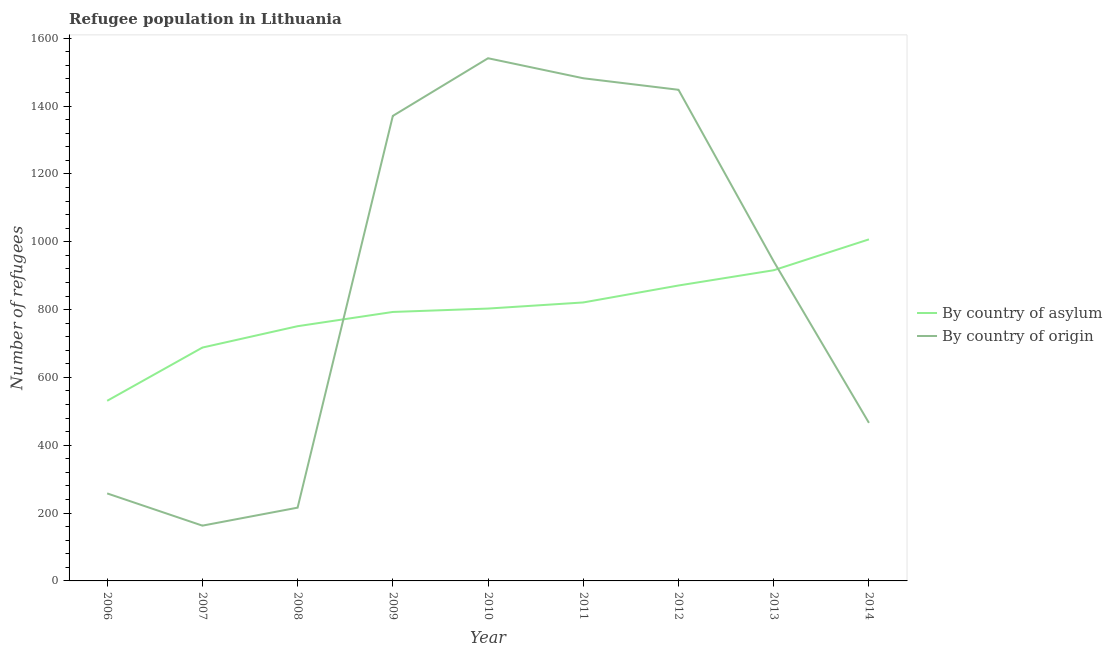How many different coloured lines are there?
Your answer should be very brief. 2. Does the line corresponding to number of refugees by country of asylum intersect with the line corresponding to number of refugees by country of origin?
Give a very brief answer. Yes. What is the number of refugees by country of asylum in 2012?
Provide a short and direct response. 871. Across all years, what is the maximum number of refugees by country of asylum?
Ensure brevity in your answer.  1007. Across all years, what is the minimum number of refugees by country of origin?
Make the answer very short. 163. In which year was the number of refugees by country of asylum minimum?
Keep it short and to the point. 2006. What is the total number of refugees by country of asylum in the graph?
Your answer should be very brief. 7181. What is the difference between the number of refugees by country of asylum in 2008 and that in 2013?
Your response must be concise. -165. What is the difference between the number of refugees by country of origin in 2008 and the number of refugees by country of asylum in 2007?
Your answer should be very brief. -472. What is the average number of refugees by country of origin per year?
Offer a terse response. 876.33. In the year 2011, what is the difference between the number of refugees by country of asylum and number of refugees by country of origin?
Ensure brevity in your answer.  -661. What is the ratio of the number of refugees by country of origin in 2011 to that in 2014?
Your answer should be very brief. 3.18. What is the difference between the highest and the second highest number of refugees by country of asylum?
Ensure brevity in your answer.  91. What is the difference between the highest and the lowest number of refugees by country of origin?
Offer a terse response. 1378. In how many years, is the number of refugees by country of origin greater than the average number of refugees by country of origin taken over all years?
Your answer should be very brief. 5. Is the sum of the number of refugees by country of origin in 2011 and 2012 greater than the maximum number of refugees by country of asylum across all years?
Your answer should be very brief. Yes. Is the number of refugees by country of asylum strictly greater than the number of refugees by country of origin over the years?
Give a very brief answer. No. Is the number of refugees by country of origin strictly less than the number of refugees by country of asylum over the years?
Ensure brevity in your answer.  No. How many lines are there?
Your response must be concise. 2. Does the graph contain any zero values?
Make the answer very short. No. Where does the legend appear in the graph?
Ensure brevity in your answer.  Center right. How are the legend labels stacked?
Keep it short and to the point. Vertical. What is the title of the graph?
Your answer should be compact. Refugee population in Lithuania. What is the label or title of the X-axis?
Your answer should be very brief. Year. What is the label or title of the Y-axis?
Give a very brief answer. Number of refugees. What is the Number of refugees of By country of asylum in 2006?
Keep it short and to the point. 531. What is the Number of refugees in By country of origin in 2006?
Provide a succinct answer. 258. What is the Number of refugees of By country of asylum in 2007?
Your answer should be very brief. 688. What is the Number of refugees of By country of origin in 2007?
Your answer should be compact. 163. What is the Number of refugees of By country of asylum in 2008?
Ensure brevity in your answer.  751. What is the Number of refugees in By country of origin in 2008?
Keep it short and to the point. 216. What is the Number of refugees in By country of asylum in 2009?
Your answer should be compact. 793. What is the Number of refugees of By country of origin in 2009?
Offer a terse response. 1371. What is the Number of refugees of By country of asylum in 2010?
Ensure brevity in your answer.  803. What is the Number of refugees of By country of origin in 2010?
Offer a terse response. 1541. What is the Number of refugees in By country of asylum in 2011?
Give a very brief answer. 821. What is the Number of refugees in By country of origin in 2011?
Offer a terse response. 1482. What is the Number of refugees of By country of asylum in 2012?
Your response must be concise. 871. What is the Number of refugees in By country of origin in 2012?
Provide a short and direct response. 1448. What is the Number of refugees of By country of asylum in 2013?
Keep it short and to the point. 916. What is the Number of refugees in By country of origin in 2013?
Provide a short and direct response. 942. What is the Number of refugees of By country of asylum in 2014?
Your answer should be compact. 1007. What is the Number of refugees of By country of origin in 2014?
Ensure brevity in your answer.  466. Across all years, what is the maximum Number of refugees of By country of asylum?
Ensure brevity in your answer.  1007. Across all years, what is the maximum Number of refugees of By country of origin?
Your response must be concise. 1541. Across all years, what is the minimum Number of refugees in By country of asylum?
Offer a terse response. 531. Across all years, what is the minimum Number of refugees of By country of origin?
Ensure brevity in your answer.  163. What is the total Number of refugees in By country of asylum in the graph?
Your response must be concise. 7181. What is the total Number of refugees of By country of origin in the graph?
Offer a terse response. 7887. What is the difference between the Number of refugees of By country of asylum in 2006 and that in 2007?
Provide a succinct answer. -157. What is the difference between the Number of refugees of By country of origin in 2006 and that in 2007?
Offer a very short reply. 95. What is the difference between the Number of refugees in By country of asylum in 2006 and that in 2008?
Ensure brevity in your answer.  -220. What is the difference between the Number of refugees in By country of origin in 2006 and that in 2008?
Your answer should be compact. 42. What is the difference between the Number of refugees of By country of asylum in 2006 and that in 2009?
Keep it short and to the point. -262. What is the difference between the Number of refugees of By country of origin in 2006 and that in 2009?
Offer a very short reply. -1113. What is the difference between the Number of refugees in By country of asylum in 2006 and that in 2010?
Keep it short and to the point. -272. What is the difference between the Number of refugees in By country of origin in 2006 and that in 2010?
Give a very brief answer. -1283. What is the difference between the Number of refugees of By country of asylum in 2006 and that in 2011?
Give a very brief answer. -290. What is the difference between the Number of refugees in By country of origin in 2006 and that in 2011?
Your response must be concise. -1224. What is the difference between the Number of refugees of By country of asylum in 2006 and that in 2012?
Keep it short and to the point. -340. What is the difference between the Number of refugees of By country of origin in 2006 and that in 2012?
Give a very brief answer. -1190. What is the difference between the Number of refugees in By country of asylum in 2006 and that in 2013?
Make the answer very short. -385. What is the difference between the Number of refugees of By country of origin in 2006 and that in 2013?
Provide a succinct answer. -684. What is the difference between the Number of refugees of By country of asylum in 2006 and that in 2014?
Your response must be concise. -476. What is the difference between the Number of refugees in By country of origin in 2006 and that in 2014?
Offer a very short reply. -208. What is the difference between the Number of refugees of By country of asylum in 2007 and that in 2008?
Offer a very short reply. -63. What is the difference between the Number of refugees of By country of origin in 2007 and that in 2008?
Your answer should be very brief. -53. What is the difference between the Number of refugees of By country of asylum in 2007 and that in 2009?
Give a very brief answer. -105. What is the difference between the Number of refugees in By country of origin in 2007 and that in 2009?
Make the answer very short. -1208. What is the difference between the Number of refugees in By country of asylum in 2007 and that in 2010?
Provide a succinct answer. -115. What is the difference between the Number of refugees in By country of origin in 2007 and that in 2010?
Provide a succinct answer. -1378. What is the difference between the Number of refugees in By country of asylum in 2007 and that in 2011?
Your answer should be very brief. -133. What is the difference between the Number of refugees of By country of origin in 2007 and that in 2011?
Your answer should be compact. -1319. What is the difference between the Number of refugees in By country of asylum in 2007 and that in 2012?
Keep it short and to the point. -183. What is the difference between the Number of refugees in By country of origin in 2007 and that in 2012?
Your response must be concise. -1285. What is the difference between the Number of refugees of By country of asylum in 2007 and that in 2013?
Ensure brevity in your answer.  -228. What is the difference between the Number of refugees in By country of origin in 2007 and that in 2013?
Give a very brief answer. -779. What is the difference between the Number of refugees of By country of asylum in 2007 and that in 2014?
Provide a short and direct response. -319. What is the difference between the Number of refugees of By country of origin in 2007 and that in 2014?
Offer a terse response. -303. What is the difference between the Number of refugees of By country of asylum in 2008 and that in 2009?
Ensure brevity in your answer.  -42. What is the difference between the Number of refugees in By country of origin in 2008 and that in 2009?
Ensure brevity in your answer.  -1155. What is the difference between the Number of refugees in By country of asylum in 2008 and that in 2010?
Provide a succinct answer. -52. What is the difference between the Number of refugees in By country of origin in 2008 and that in 2010?
Your answer should be compact. -1325. What is the difference between the Number of refugees of By country of asylum in 2008 and that in 2011?
Offer a very short reply. -70. What is the difference between the Number of refugees in By country of origin in 2008 and that in 2011?
Offer a terse response. -1266. What is the difference between the Number of refugees of By country of asylum in 2008 and that in 2012?
Ensure brevity in your answer.  -120. What is the difference between the Number of refugees of By country of origin in 2008 and that in 2012?
Give a very brief answer. -1232. What is the difference between the Number of refugees of By country of asylum in 2008 and that in 2013?
Make the answer very short. -165. What is the difference between the Number of refugees of By country of origin in 2008 and that in 2013?
Provide a short and direct response. -726. What is the difference between the Number of refugees of By country of asylum in 2008 and that in 2014?
Provide a succinct answer. -256. What is the difference between the Number of refugees in By country of origin in 2008 and that in 2014?
Offer a terse response. -250. What is the difference between the Number of refugees in By country of origin in 2009 and that in 2010?
Keep it short and to the point. -170. What is the difference between the Number of refugees of By country of asylum in 2009 and that in 2011?
Make the answer very short. -28. What is the difference between the Number of refugees in By country of origin in 2009 and that in 2011?
Give a very brief answer. -111. What is the difference between the Number of refugees of By country of asylum in 2009 and that in 2012?
Your response must be concise. -78. What is the difference between the Number of refugees of By country of origin in 2009 and that in 2012?
Your answer should be compact. -77. What is the difference between the Number of refugees in By country of asylum in 2009 and that in 2013?
Offer a very short reply. -123. What is the difference between the Number of refugees of By country of origin in 2009 and that in 2013?
Keep it short and to the point. 429. What is the difference between the Number of refugees in By country of asylum in 2009 and that in 2014?
Your answer should be very brief. -214. What is the difference between the Number of refugees in By country of origin in 2009 and that in 2014?
Make the answer very short. 905. What is the difference between the Number of refugees in By country of asylum in 2010 and that in 2011?
Ensure brevity in your answer.  -18. What is the difference between the Number of refugees in By country of origin in 2010 and that in 2011?
Your answer should be compact. 59. What is the difference between the Number of refugees of By country of asylum in 2010 and that in 2012?
Make the answer very short. -68. What is the difference between the Number of refugees in By country of origin in 2010 and that in 2012?
Keep it short and to the point. 93. What is the difference between the Number of refugees in By country of asylum in 2010 and that in 2013?
Give a very brief answer. -113. What is the difference between the Number of refugees in By country of origin in 2010 and that in 2013?
Ensure brevity in your answer.  599. What is the difference between the Number of refugees of By country of asylum in 2010 and that in 2014?
Offer a very short reply. -204. What is the difference between the Number of refugees of By country of origin in 2010 and that in 2014?
Keep it short and to the point. 1075. What is the difference between the Number of refugees of By country of asylum in 2011 and that in 2012?
Ensure brevity in your answer.  -50. What is the difference between the Number of refugees in By country of origin in 2011 and that in 2012?
Provide a short and direct response. 34. What is the difference between the Number of refugees of By country of asylum in 2011 and that in 2013?
Give a very brief answer. -95. What is the difference between the Number of refugees of By country of origin in 2011 and that in 2013?
Make the answer very short. 540. What is the difference between the Number of refugees in By country of asylum in 2011 and that in 2014?
Make the answer very short. -186. What is the difference between the Number of refugees in By country of origin in 2011 and that in 2014?
Give a very brief answer. 1016. What is the difference between the Number of refugees of By country of asylum in 2012 and that in 2013?
Your answer should be compact. -45. What is the difference between the Number of refugees in By country of origin in 2012 and that in 2013?
Provide a short and direct response. 506. What is the difference between the Number of refugees of By country of asylum in 2012 and that in 2014?
Keep it short and to the point. -136. What is the difference between the Number of refugees of By country of origin in 2012 and that in 2014?
Your answer should be very brief. 982. What is the difference between the Number of refugees in By country of asylum in 2013 and that in 2014?
Keep it short and to the point. -91. What is the difference between the Number of refugees of By country of origin in 2013 and that in 2014?
Keep it short and to the point. 476. What is the difference between the Number of refugees in By country of asylum in 2006 and the Number of refugees in By country of origin in 2007?
Ensure brevity in your answer.  368. What is the difference between the Number of refugees of By country of asylum in 2006 and the Number of refugees of By country of origin in 2008?
Your answer should be compact. 315. What is the difference between the Number of refugees in By country of asylum in 2006 and the Number of refugees in By country of origin in 2009?
Your response must be concise. -840. What is the difference between the Number of refugees in By country of asylum in 2006 and the Number of refugees in By country of origin in 2010?
Offer a terse response. -1010. What is the difference between the Number of refugees in By country of asylum in 2006 and the Number of refugees in By country of origin in 2011?
Offer a very short reply. -951. What is the difference between the Number of refugees of By country of asylum in 2006 and the Number of refugees of By country of origin in 2012?
Ensure brevity in your answer.  -917. What is the difference between the Number of refugees of By country of asylum in 2006 and the Number of refugees of By country of origin in 2013?
Your response must be concise. -411. What is the difference between the Number of refugees of By country of asylum in 2006 and the Number of refugees of By country of origin in 2014?
Your response must be concise. 65. What is the difference between the Number of refugees of By country of asylum in 2007 and the Number of refugees of By country of origin in 2008?
Make the answer very short. 472. What is the difference between the Number of refugees in By country of asylum in 2007 and the Number of refugees in By country of origin in 2009?
Offer a very short reply. -683. What is the difference between the Number of refugees in By country of asylum in 2007 and the Number of refugees in By country of origin in 2010?
Keep it short and to the point. -853. What is the difference between the Number of refugees of By country of asylum in 2007 and the Number of refugees of By country of origin in 2011?
Offer a very short reply. -794. What is the difference between the Number of refugees of By country of asylum in 2007 and the Number of refugees of By country of origin in 2012?
Offer a terse response. -760. What is the difference between the Number of refugees in By country of asylum in 2007 and the Number of refugees in By country of origin in 2013?
Make the answer very short. -254. What is the difference between the Number of refugees in By country of asylum in 2007 and the Number of refugees in By country of origin in 2014?
Your response must be concise. 222. What is the difference between the Number of refugees of By country of asylum in 2008 and the Number of refugees of By country of origin in 2009?
Provide a short and direct response. -620. What is the difference between the Number of refugees in By country of asylum in 2008 and the Number of refugees in By country of origin in 2010?
Make the answer very short. -790. What is the difference between the Number of refugees of By country of asylum in 2008 and the Number of refugees of By country of origin in 2011?
Provide a short and direct response. -731. What is the difference between the Number of refugees in By country of asylum in 2008 and the Number of refugees in By country of origin in 2012?
Your answer should be compact. -697. What is the difference between the Number of refugees of By country of asylum in 2008 and the Number of refugees of By country of origin in 2013?
Offer a very short reply. -191. What is the difference between the Number of refugees of By country of asylum in 2008 and the Number of refugees of By country of origin in 2014?
Offer a very short reply. 285. What is the difference between the Number of refugees of By country of asylum in 2009 and the Number of refugees of By country of origin in 2010?
Offer a terse response. -748. What is the difference between the Number of refugees of By country of asylum in 2009 and the Number of refugees of By country of origin in 2011?
Make the answer very short. -689. What is the difference between the Number of refugees in By country of asylum in 2009 and the Number of refugees in By country of origin in 2012?
Ensure brevity in your answer.  -655. What is the difference between the Number of refugees of By country of asylum in 2009 and the Number of refugees of By country of origin in 2013?
Provide a short and direct response. -149. What is the difference between the Number of refugees in By country of asylum in 2009 and the Number of refugees in By country of origin in 2014?
Ensure brevity in your answer.  327. What is the difference between the Number of refugees in By country of asylum in 2010 and the Number of refugees in By country of origin in 2011?
Offer a very short reply. -679. What is the difference between the Number of refugees in By country of asylum in 2010 and the Number of refugees in By country of origin in 2012?
Ensure brevity in your answer.  -645. What is the difference between the Number of refugees in By country of asylum in 2010 and the Number of refugees in By country of origin in 2013?
Give a very brief answer. -139. What is the difference between the Number of refugees in By country of asylum in 2010 and the Number of refugees in By country of origin in 2014?
Make the answer very short. 337. What is the difference between the Number of refugees of By country of asylum in 2011 and the Number of refugees of By country of origin in 2012?
Your answer should be compact. -627. What is the difference between the Number of refugees of By country of asylum in 2011 and the Number of refugees of By country of origin in 2013?
Ensure brevity in your answer.  -121. What is the difference between the Number of refugees of By country of asylum in 2011 and the Number of refugees of By country of origin in 2014?
Your answer should be very brief. 355. What is the difference between the Number of refugees of By country of asylum in 2012 and the Number of refugees of By country of origin in 2013?
Give a very brief answer. -71. What is the difference between the Number of refugees of By country of asylum in 2012 and the Number of refugees of By country of origin in 2014?
Keep it short and to the point. 405. What is the difference between the Number of refugees of By country of asylum in 2013 and the Number of refugees of By country of origin in 2014?
Ensure brevity in your answer.  450. What is the average Number of refugees of By country of asylum per year?
Ensure brevity in your answer.  797.89. What is the average Number of refugees of By country of origin per year?
Ensure brevity in your answer.  876.33. In the year 2006, what is the difference between the Number of refugees in By country of asylum and Number of refugees in By country of origin?
Keep it short and to the point. 273. In the year 2007, what is the difference between the Number of refugees in By country of asylum and Number of refugees in By country of origin?
Offer a terse response. 525. In the year 2008, what is the difference between the Number of refugees in By country of asylum and Number of refugees in By country of origin?
Provide a succinct answer. 535. In the year 2009, what is the difference between the Number of refugees of By country of asylum and Number of refugees of By country of origin?
Your answer should be very brief. -578. In the year 2010, what is the difference between the Number of refugees of By country of asylum and Number of refugees of By country of origin?
Offer a terse response. -738. In the year 2011, what is the difference between the Number of refugees in By country of asylum and Number of refugees in By country of origin?
Provide a succinct answer. -661. In the year 2012, what is the difference between the Number of refugees in By country of asylum and Number of refugees in By country of origin?
Offer a very short reply. -577. In the year 2014, what is the difference between the Number of refugees of By country of asylum and Number of refugees of By country of origin?
Provide a succinct answer. 541. What is the ratio of the Number of refugees in By country of asylum in 2006 to that in 2007?
Ensure brevity in your answer.  0.77. What is the ratio of the Number of refugees of By country of origin in 2006 to that in 2007?
Make the answer very short. 1.58. What is the ratio of the Number of refugees in By country of asylum in 2006 to that in 2008?
Keep it short and to the point. 0.71. What is the ratio of the Number of refugees of By country of origin in 2006 to that in 2008?
Give a very brief answer. 1.19. What is the ratio of the Number of refugees of By country of asylum in 2006 to that in 2009?
Your answer should be very brief. 0.67. What is the ratio of the Number of refugees of By country of origin in 2006 to that in 2009?
Offer a very short reply. 0.19. What is the ratio of the Number of refugees of By country of asylum in 2006 to that in 2010?
Ensure brevity in your answer.  0.66. What is the ratio of the Number of refugees of By country of origin in 2006 to that in 2010?
Ensure brevity in your answer.  0.17. What is the ratio of the Number of refugees in By country of asylum in 2006 to that in 2011?
Give a very brief answer. 0.65. What is the ratio of the Number of refugees in By country of origin in 2006 to that in 2011?
Ensure brevity in your answer.  0.17. What is the ratio of the Number of refugees in By country of asylum in 2006 to that in 2012?
Your answer should be very brief. 0.61. What is the ratio of the Number of refugees of By country of origin in 2006 to that in 2012?
Give a very brief answer. 0.18. What is the ratio of the Number of refugees in By country of asylum in 2006 to that in 2013?
Keep it short and to the point. 0.58. What is the ratio of the Number of refugees in By country of origin in 2006 to that in 2013?
Offer a terse response. 0.27. What is the ratio of the Number of refugees of By country of asylum in 2006 to that in 2014?
Your response must be concise. 0.53. What is the ratio of the Number of refugees of By country of origin in 2006 to that in 2014?
Your answer should be compact. 0.55. What is the ratio of the Number of refugees in By country of asylum in 2007 to that in 2008?
Provide a succinct answer. 0.92. What is the ratio of the Number of refugees of By country of origin in 2007 to that in 2008?
Offer a very short reply. 0.75. What is the ratio of the Number of refugees in By country of asylum in 2007 to that in 2009?
Offer a terse response. 0.87. What is the ratio of the Number of refugees in By country of origin in 2007 to that in 2009?
Your answer should be compact. 0.12. What is the ratio of the Number of refugees of By country of asylum in 2007 to that in 2010?
Make the answer very short. 0.86. What is the ratio of the Number of refugees in By country of origin in 2007 to that in 2010?
Keep it short and to the point. 0.11. What is the ratio of the Number of refugees in By country of asylum in 2007 to that in 2011?
Your answer should be compact. 0.84. What is the ratio of the Number of refugees of By country of origin in 2007 to that in 2011?
Give a very brief answer. 0.11. What is the ratio of the Number of refugees in By country of asylum in 2007 to that in 2012?
Give a very brief answer. 0.79. What is the ratio of the Number of refugees of By country of origin in 2007 to that in 2012?
Ensure brevity in your answer.  0.11. What is the ratio of the Number of refugees of By country of asylum in 2007 to that in 2013?
Your answer should be very brief. 0.75. What is the ratio of the Number of refugees of By country of origin in 2007 to that in 2013?
Your response must be concise. 0.17. What is the ratio of the Number of refugees of By country of asylum in 2007 to that in 2014?
Your response must be concise. 0.68. What is the ratio of the Number of refugees in By country of origin in 2007 to that in 2014?
Give a very brief answer. 0.35. What is the ratio of the Number of refugees in By country of asylum in 2008 to that in 2009?
Your answer should be very brief. 0.95. What is the ratio of the Number of refugees of By country of origin in 2008 to that in 2009?
Give a very brief answer. 0.16. What is the ratio of the Number of refugees of By country of asylum in 2008 to that in 2010?
Keep it short and to the point. 0.94. What is the ratio of the Number of refugees in By country of origin in 2008 to that in 2010?
Provide a short and direct response. 0.14. What is the ratio of the Number of refugees of By country of asylum in 2008 to that in 2011?
Offer a terse response. 0.91. What is the ratio of the Number of refugees in By country of origin in 2008 to that in 2011?
Provide a succinct answer. 0.15. What is the ratio of the Number of refugees of By country of asylum in 2008 to that in 2012?
Your answer should be very brief. 0.86. What is the ratio of the Number of refugees of By country of origin in 2008 to that in 2012?
Offer a terse response. 0.15. What is the ratio of the Number of refugees of By country of asylum in 2008 to that in 2013?
Provide a short and direct response. 0.82. What is the ratio of the Number of refugees of By country of origin in 2008 to that in 2013?
Keep it short and to the point. 0.23. What is the ratio of the Number of refugees in By country of asylum in 2008 to that in 2014?
Provide a short and direct response. 0.75. What is the ratio of the Number of refugees in By country of origin in 2008 to that in 2014?
Provide a short and direct response. 0.46. What is the ratio of the Number of refugees of By country of asylum in 2009 to that in 2010?
Your response must be concise. 0.99. What is the ratio of the Number of refugees of By country of origin in 2009 to that in 2010?
Ensure brevity in your answer.  0.89. What is the ratio of the Number of refugees in By country of asylum in 2009 to that in 2011?
Ensure brevity in your answer.  0.97. What is the ratio of the Number of refugees in By country of origin in 2009 to that in 2011?
Keep it short and to the point. 0.93. What is the ratio of the Number of refugees in By country of asylum in 2009 to that in 2012?
Your response must be concise. 0.91. What is the ratio of the Number of refugees in By country of origin in 2009 to that in 2012?
Your answer should be very brief. 0.95. What is the ratio of the Number of refugees in By country of asylum in 2009 to that in 2013?
Offer a very short reply. 0.87. What is the ratio of the Number of refugees in By country of origin in 2009 to that in 2013?
Ensure brevity in your answer.  1.46. What is the ratio of the Number of refugees of By country of asylum in 2009 to that in 2014?
Your response must be concise. 0.79. What is the ratio of the Number of refugees in By country of origin in 2009 to that in 2014?
Your response must be concise. 2.94. What is the ratio of the Number of refugees of By country of asylum in 2010 to that in 2011?
Ensure brevity in your answer.  0.98. What is the ratio of the Number of refugees in By country of origin in 2010 to that in 2011?
Your response must be concise. 1.04. What is the ratio of the Number of refugees in By country of asylum in 2010 to that in 2012?
Your answer should be very brief. 0.92. What is the ratio of the Number of refugees in By country of origin in 2010 to that in 2012?
Ensure brevity in your answer.  1.06. What is the ratio of the Number of refugees in By country of asylum in 2010 to that in 2013?
Provide a succinct answer. 0.88. What is the ratio of the Number of refugees in By country of origin in 2010 to that in 2013?
Give a very brief answer. 1.64. What is the ratio of the Number of refugees of By country of asylum in 2010 to that in 2014?
Your response must be concise. 0.8. What is the ratio of the Number of refugees of By country of origin in 2010 to that in 2014?
Your answer should be very brief. 3.31. What is the ratio of the Number of refugees of By country of asylum in 2011 to that in 2012?
Your response must be concise. 0.94. What is the ratio of the Number of refugees of By country of origin in 2011 to that in 2012?
Make the answer very short. 1.02. What is the ratio of the Number of refugees of By country of asylum in 2011 to that in 2013?
Make the answer very short. 0.9. What is the ratio of the Number of refugees in By country of origin in 2011 to that in 2013?
Your response must be concise. 1.57. What is the ratio of the Number of refugees of By country of asylum in 2011 to that in 2014?
Your response must be concise. 0.82. What is the ratio of the Number of refugees in By country of origin in 2011 to that in 2014?
Keep it short and to the point. 3.18. What is the ratio of the Number of refugees in By country of asylum in 2012 to that in 2013?
Provide a succinct answer. 0.95. What is the ratio of the Number of refugees of By country of origin in 2012 to that in 2013?
Give a very brief answer. 1.54. What is the ratio of the Number of refugees of By country of asylum in 2012 to that in 2014?
Give a very brief answer. 0.86. What is the ratio of the Number of refugees in By country of origin in 2012 to that in 2014?
Offer a very short reply. 3.11. What is the ratio of the Number of refugees in By country of asylum in 2013 to that in 2014?
Provide a succinct answer. 0.91. What is the ratio of the Number of refugees of By country of origin in 2013 to that in 2014?
Your answer should be very brief. 2.02. What is the difference between the highest and the second highest Number of refugees of By country of asylum?
Provide a short and direct response. 91. What is the difference between the highest and the second highest Number of refugees of By country of origin?
Offer a very short reply. 59. What is the difference between the highest and the lowest Number of refugees in By country of asylum?
Ensure brevity in your answer.  476. What is the difference between the highest and the lowest Number of refugees in By country of origin?
Your response must be concise. 1378. 